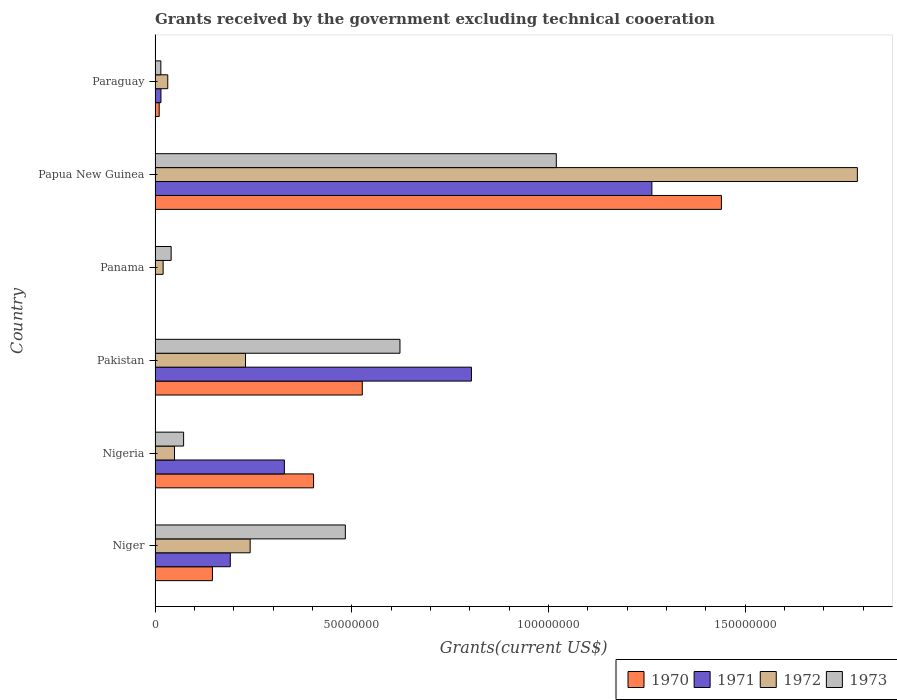How many groups of bars are there?
Offer a very short reply. 6. How many bars are there on the 1st tick from the top?
Ensure brevity in your answer.  4. What is the label of the 3rd group of bars from the top?
Provide a succinct answer. Panama. What is the total grants received by the government in 1973 in Pakistan?
Your answer should be compact. 6.23e+07. Across all countries, what is the maximum total grants received by the government in 1971?
Give a very brief answer. 1.26e+08. Across all countries, what is the minimum total grants received by the government in 1972?
Your response must be concise. 2.05e+06. In which country was the total grants received by the government in 1971 maximum?
Your response must be concise. Papua New Guinea. What is the total total grants received by the government in 1970 in the graph?
Provide a succinct answer. 2.53e+08. What is the difference between the total grants received by the government in 1973 in Papua New Guinea and that in Paraguay?
Provide a succinct answer. 1.01e+08. What is the difference between the total grants received by the government in 1972 in Nigeria and the total grants received by the government in 1973 in Niger?
Your answer should be compact. -4.34e+07. What is the average total grants received by the government in 1970 per country?
Keep it short and to the point. 4.21e+07. What is the difference between the total grants received by the government in 1970 and total grants received by the government in 1971 in Papua New Guinea?
Offer a very short reply. 1.77e+07. What is the ratio of the total grants received by the government in 1972 in Panama to that in Papua New Guinea?
Offer a very short reply. 0.01. Is the total grants received by the government in 1973 in Panama less than that in Paraguay?
Offer a very short reply. No. What is the difference between the highest and the second highest total grants received by the government in 1972?
Keep it short and to the point. 1.54e+08. What is the difference between the highest and the lowest total grants received by the government in 1971?
Your answer should be very brief. 1.26e+08. In how many countries, is the total grants received by the government in 1972 greater than the average total grants received by the government in 1972 taken over all countries?
Your answer should be compact. 1. Is the sum of the total grants received by the government in 1970 in Pakistan and Paraguay greater than the maximum total grants received by the government in 1973 across all countries?
Your answer should be compact. No. Is it the case that in every country, the sum of the total grants received by the government in 1971 and total grants received by the government in 1970 is greater than the sum of total grants received by the government in 1972 and total grants received by the government in 1973?
Your answer should be very brief. No. Are all the bars in the graph horizontal?
Provide a short and direct response. Yes. What is the difference between two consecutive major ticks on the X-axis?
Ensure brevity in your answer.  5.00e+07. Are the values on the major ticks of X-axis written in scientific E-notation?
Your response must be concise. No. Does the graph contain grids?
Provide a succinct answer. No. What is the title of the graph?
Your answer should be compact. Grants received by the government excluding technical cooeration. What is the label or title of the X-axis?
Offer a very short reply. Grants(current US$). What is the Grants(current US$) of 1970 in Niger?
Give a very brief answer. 1.46e+07. What is the Grants(current US$) in 1971 in Niger?
Make the answer very short. 1.91e+07. What is the Grants(current US$) in 1972 in Niger?
Give a very brief answer. 2.42e+07. What is the Grants(current US$) in 1973 in Niger?
Give a very brief answer. 4.84e+07. What is the Grants(current US$) of 1970 in Nigeria?
Offer a terse response. 4.03e+07. What is the Grants(current US$) in 1971 in Nigeria?
Offer a terse response. 3.29e+07. What is the Grants(current US$) of 1972 in Nigeria?
Your answer should be compact. 4.94e+06. What is the Grants(current US$) of 1973 in Nigeria?
Offer a very short reply. 7.26e+06. What is the Grants(current US$) in 1970 in Pakistan?
Provide a succinct answer. 5.27e+07. What is the Grants(current US$) of 1971 in Pakistan?
Keep it short and to the point. 8.04e+07. What is the Grants(current US$) of 1972 in Pakistan?
Your answer should be very brief. 2.30e+07. What is the Grants(current US$) of 1973 in Pakistan?
Make the answer very short. 6.23e+07. What is the Grants(current US$) in 1971 in Panama?
Offer a terse response. 1.10e+05. What is the Grants(current US$) of 1972 in Panama?
Provide a short and direct response. 2.05e+06. What is the Grants(current US$) in 1973 in Panama?
Your response must be concise. 4.09e+06. What is the Grants(current US$) in 1970 in Papua New Guinea?
Ensure brevity in your answer.  1.44e+08. What is the Grants(current US$) of 1971 in Papua New Guinea?
Offer a terse response. 1.26e+08. What is the Grants(current US$) in 1972 in Papua New Guinea?
Keep it short and to the point. 1.79e+08. What is the Grants(current US$) in 1973 in Papua New Guinea?
Give a very brief answer. 1.02e+08. What is the Grants(current US$) of 1970 in Paraguay?
Provide a short and direct response. 1.05e+06. What is the Grants(current US$) of 1971 in Paraguay?
Your answer should be very brief. 1.50e+06. What is the Grants(current US$) of 1972 in Paraguay?
Offer a very short reply. 3.23e+06. What is the Grants(current US$) in 1973 in Paraguay?
Your answer should be compact. 1.47e+06. Across all countries, what is the maximum Grants(current US$) in 1970?
Offer a very short reply. 1.44e+08. Across all countries, what is the maximum Grants(current US$) of 1971?
Offer a terse response. 1.26e+08. Across all countries, what is the maximum Grants(current US$) in 1972?
Provide a succinct answer. 1.79e+08. Across all countries, what is the maximum Grants(current US$) of 1973?
Your answer should be very brief. 1.02e+08. Across all countries, what is the minimum Grants(current US$) in 1970?
Your answer should be very brief. 0. Across all countries, what is the minimum Grants(current US$) in 1971?
Offer a terse response. 1.10e+05. Across all countries, what is the minimum Grants(current US$) in 1972?
Make the answer very short. 2.05e+06. Across all countries, what is the minimum Grants(current US$) of 1973?
Keep it short and to the point. 1.47e+06. What is the total Grants(current US$) of 1970 in the graph?
Provide a short and direct response. 2.53e+08. What is the total Grants(current US$) in 1971 in the graph?
Your answer should be very brief. 2.60e+08. What is the total Grants(current US$) of 1972 in the graph?
Make the answer very short. 2.36e+08. What is the total Grants(current US$) of 1973 in the graph?
Give a very brief answer. 2.25e+08. What is the difference between the Grants(current US$) in 1970 in Niger and that in Nigeria?
Provide a succinct answer. -2.57e+07. What is the difference between the Grants(current US$) of 1971 in Niger and that in Nigeria?
Give a very brief answer. -1.38e+07. What is the difference between the Grants(current US$) of 1972 in Niger and that in Nigeria?
Make the answer very short. 1.92e+07. What is the difference between the Grants(current US$) in 1973 in Niger and that in Nigeria?
Your answer should be compact. 4.11e+07. What is the difference between the Grants(current US$) of 1970 in Niger and that in Pakistan?
Make the answer very short. -3.81e+07. What is the difference between the Grants(current US$) of 1971 in Niger and that in Pakistan?
Make the answer very short. -6.13e+07. What is the difference between the Grants(current US$) of 1972 in Niger and that in Pakistan?
Keep it short and to the point. 1.18e+06. What is the difference between the Grants(current US$) in 1973 in Niger and that in Pakistan?
Your response must be concise. -1.39e+07. What is the difference between the Grants(current US$) of 1971 in Niger and that in Panama?
Your answer should be very brief. 1.90e+07. What is the difference between the Grants(current US$) in 1972 in Niger and that in Panama?
Provide a short and direct response. 2.21e+07. What is the difference between the Grants(current US$) of 1973 in Niger and that in Panama?
Your answer should be compact. 4.43e+07. What is the difference between the Grants(current US$) of 1970 in Niger and that in Papua New Guinea?
Your answer should be very brief. -1.29e+08. What is the difference between the Grants(current US$) of 1971 in Niger and that in Papua New Guinea?
Give a very brief answer. -1.07e+08. What is the difference between the Grants(current US$) in 1972 in Niger and that in Papua New Guinea?
Your response must be concise. -1.54e+08. What is the difference between the Grants(current US$) in 1973 in Niger and that in Papua New Guinea?
Offer a very short reply. -5.36e+07. What is the difference between the Grants(current US$) in 1970 in Niger and that in Paraguay?
Provide a short and direct response. 1.35e+07. What is the difference between the Grants(current US$) in 1971 in Niger and that in Paraguay?
Offer a very short reply. 1.76e+07. What is the difference between the Grants(current US$) of 1972 in Niger and that in Paraguay?
Provide a short and direct response. 2.10e+07. What is the difference between the Grants(current US$) in 1973 in Niger and that in Paraguay?
Your response must be concise. 4.69e+07. What is the difference between the Grants(current US$) in 1970 in Nigeria and that in Pakistan?
Give a very brief answer. -1.24e+07. What is the difference between the Grants(current US$) in 1971 in Nigeria and that in Pakistan?
Offer a very short reply. -4.76e+07. What is the difference between the Grants(current US$) of 1972 in Nigeria and that in Pakistan?
Keep it short and to the point. -1.81e+07. What is the difference between the Grants(current US$) in 1973 in Nigeria and that in Pakistan?
Give a very brief answer. -5.50e+07. What is the difference between the Grants(current US$) in 1971 in Nigeria and that in Panama?
Offer a terse response. 3.28e+07. What is the difference between the Grants(current US$) in 1972 in Nigeria and that in Panama?
Provide a succinct answer. 2.89e+06. What is the difference between the Grants(current US$) in 1973 in Nigeria and that in Panama?
Provide a succinct answer. 3.17e+06. What is the difference between the Grants(current US$) of 1970 in Nigeria and that in Papua New Guinea?
Offer a terse response. -1.04e+08. What is the difference between the Grants(current US$) in 1971 in Nigeria and that in Papua New Guinea?
Give a very brief answer. -9.34e+07. What is the difference between the Grants(current US$) in 1972 in Nigeria and that in Papua New Guinea?
Keep it short and to the point. -1.74e+08. What is the difference between the Grants(current US$) in 1973 in Nigeria and that in Papua New Guinea?
Ensure brevity in your answer.  -9.48e+07. What is the difference between the Grants(current US$) in 1970 in Nigeria and that in Paraguay?
Offer a very short reply. 3.92e+07. What is the difference between the Grants(current US$) in 1971 in Nigeria and that in Paraguay?
Your answer should be very brief. 3.14e+07. What is the difference between the Grants(current US$) in 1972 in Nigeria and that in Paraguay?
Your answer should be very brief. 1.71e+06. What is the difference between the Grants(current US$) of 1973 in Nigeria and that in Paraguay?
Your answer should be compact. 5.79e+06. What is the difference between the Grants(current US$) in 1971 in Pakistan and that in Panama?
Your answer should be compact. 8.03e+07. What is the difference between the Grants(current US$) in 1972 in Pakistan and that in Panama?
Your answer should be very brief. 2.10e+07. What is the difference between the Grants(current US$) of 1973 in Pakistan and that in Panama?
Offer a terse response. 5.82e+07. What is the difference between the Grants(current US$) of 1970 in Pakistan and that in Papua New Guinea?
Provide a succinct answer. -9.13e+07. What is the difference between the Grants(current US$) in 1971 in Pakistan and that in Papua New Guinea?
Provide a succinct answer. -4.59e+07. What is the difference between the Grants(current US$) of 1972 in Pakistan and that in Papua New Guinea?
Your response must be concise. -1.56e+08. What is the difference between the Grants(current US$) in 1973 in Pakistan and that in Papua New Guinea?
Keep it short and to the point. -3.98e+07. What is the difference between the Grants(current US$) of 1970 in Pakistan and that in Paraguay?
Your response must be concise. 5.16e+07. What is the difference between the Grants(current US$) of 1971 in Pakistan and that in Paraguay?
Make the answer very short. 7.89e+07. What is the difference between the Grants(current US$) in 1972 in Pakistan and that in Paraguay?
Make the answer very short. 1.98e+07. What is the difference between the Grants(current US$) of 1973 in Pakistan and that in Paraguay?
Offer a terse response. 6.08e+07. What is the difference between the Grants(current US$) in 1971 in Panama and that in Papua New Guinea?
Provide a short and direct response. -1.26e+08. What is the difference between the Grants(current US$) of 1972 in Panama and that in Papua New Guinea?
Provide a short and direct response. -1.77e+08. What is the difference between the Grants(current US$) in 1973 in Panama and that in Papua New Guinea?
Offer a very short reply. -9.79e+07. What is the difference between the Grants(current US$) in 1971 in Panama and that in Paraguay?
Keep it short and to the point. -1.39e+06. What is the difference between the Grants(current US$) of 1972 in Panama and that in Paraguay?
Give a very brief answer. -1.18e+06. What is the difference between the Grants(current US$) of 1973 in Panama and that in Paraguay?
Keep it short and to the point. 2.62e+06. What is the difference between the Grants(current US$) in 1970 in Papua New Guinea and that in Paraguay?
Your response must be concise. 1.43e+08. What is the difference between the Grants(current US$) of 1971 in Papua New Guinea and that in Paraguay?
Offer a terse response. 1.25e+08. What is the difference between the Grants(current US$) in 1972 in Papua New Guinea and that in Paraguay?
Your answer should be compact. 1.75e+08. What is the difference between the Grants(current US$) of 1973 in Papua New Guinea and that in Paraguay?
Your answer should be compact. 1.01e+08. What is the difference between the Grants(current US$) in 1970 in Niger and the Grants(current US$) in 1971 in Nigeria?
Provide a short and direct response. -1.83e+07. What is the difference between the Grants(current US$) in 1970 in Niger and the Grants(current US$) in 1972 in Nigeria?
Offer a terse response. 9.65e+06. What is the difference between the Grants(current US$) in 1970 in Niger and the Grants(current US$) in 1973 in Nigeria?
Your response must be concise. 7.33e+06. What is the difference between the Grants(current US$) in 1971 in Niger and the Grants(current US$) in 1972 in Nigeria?
Ensure brevity in your answer.  1.42e+07. What is the difference between the Grants(current US$) of 1971 in Niger and the Grants(current US$) of 1973 in Nigeria?
Keep it short and to the point. 1.19e+07. What is the difference between the Grants(current US$) of 1972 in Niger and the Grants(current US$) of 1973 in Nigeria?
Provide a short and direct response. 1.69e+07. What is the difference between the Grants(current US$) in 1970 in Niger and the Grants(current US$) in 1971 in Pakistan?
Give a very brief answer. -6.58e+07. What is the difference between the Grants(current US$) of 1970 in Niger and the Grants(current US$) of 1972 in Pakistan?
Provide a short and direct response. -8.41e+06. What is the difference between the Grants(current US$) in 1970 in Niger and the Grants(current US$) in 1973 in Pakistan?
Keep it short and to the point. -4.77e+07. What is the difference between the Grants(current US$) in 1971 in Niger and the Grants(current US$) in 1972 in Pakistan?
Your answer should be compact. -3.87e+06. What is the difference between the Grants(current US$) in 1971 in Niger and the Grants(current US$) in 1973 in Pakistan?
Make the answer very short. -4.31e+07. What is the difference between the Grants(current US$) of 1972 in Niger and the Grants(current US$) of 1973 in Pakistan?
Provide a short and direct response. -3.81e+07. What is the difference between the Grants(current US$) in 1970 in Niger and the Grants(current US$) in 1971 in Panama?
Your answer should be very brief. 1.45e+07. What is the difference between the Grants(current US$) in 1970 in Niger and the Grants(current US$) in 1972 in Panama?
Provide a short and direct response. 1.25e+07. What is the difference between the Grants(current US$) of 1970 in Niger and the Grants(current US$) of 1973 in Panama?
Provide a succinct answer. 1.05e+07. What is the difference between the Grants(current US$) of 1971 in Niger and the Grants(current US$) of 1972 in Panama?
Your answer should be compact. 1.71e+07. What is the difference between the Grants(current US$) in 1971 in Niger and the Grants(current US$) in 1973 in Panama?
Your answer should be compact. 1.50e+07. What is the difference between the Grants(current US$) of 1972 in Niger and the Grants(current US$) of 1973 in Panama?
Offer a terse response. 2.01e+07. What is the difference between the Grants(current US$) in 1970 in Niger and the Grants(current US$) in 1971 in Papua New Guinea?
Ensure brevity in your answer.  -1.12e+08. What is the difference between the Grants(current US$) in 1970 in Niger and the Grants(current US$) in 1972 in Papua New Guinea?
Offer a very short reply. -1.64e+08. What is the difference between the Grants(current US$) in 1970 in Niger and the Grants(current US$) in 1973 in Papua New Guinea?
Your response must be concise. -8.74e+07. What is the difference between the Grants(current US$) in 1971 in Niger and the Grants(current US$) in 1972 in Papua New Guinea?
Provide a succinct answer. -1.59e+08. What is the difference between the Grants(current US$) of 1971 in Niger and the Grants(current US$) of 1973 in Papua New Guinea?
Your answer should be compact. -8.29e+07. What is the difference between the Grants(current US$) in 1972 in Niger and the Grants(current US$) in 1973 in Papua New Guinea?
Offer a very short reply. -7.78e+07. What is the difference between the Grants(current US$) of 1970 in Niger and the Grants(current US$) of 1971 in Paraguay?
Keep it short and to the point. 1.31e+07. What is the difference between the Grants(current US$) of 1970 in Niger and the Grants(current US$) of 1972 in Paraguay?
Offer a terse response. 1.14e+07. What is the difference between the Grants(current US$) in 1970 in Niger and the Grants(current US$) in 1973 in Paraguay?
Your answer should be compact. 1.31e+07. What is the difference between the Grants(current US$) of 1971 in Niger and the Grants(current US$) of 1972 in Paraguay?
Offer a terse response. 1.59e+07. What is the difference between the Grants(current US$) in 1971 in Niger and the Grants(current US$) in 1973 in Paraguay?
Your response must be concise. 1.77e+07. What is the difference between the Grants(current US$) of 1972 in Niger and the Grants(current US$) of 1973 in Paraguay?
Ensure brevity in your answer.  2.27e+07. What is the difference between the Grants(current US$) of 1970 in Nigeria and the Grants(current US$) of 1971 in Pakistan?
Make the answer very short. -4.01e+07. What is the difference between the Grants(current US$) of 1970 in Nigeria and the Grants(current US$) of 1972 in Pakistan?
Offer a very short reply. 1.73e+07. What is the difference between the Grants(current US$) in 1970 in Nigeria and the Grants(current US$) in 1973 in Pakistan?
Provide a short and direct response. -2.20e+07. What is the difference between the Grants(current US$) in 1971 in Nigeria and the Grants(current US$) in 1972 in Pakistan?
Ensure brevity in your answer.  9.88e+06. What is the difference between the Grants(current US$) in 1971 in Nigeria and the Grants(current US$) in 1973 in Pakistan?
Your answer should be very brief. -2.94e+07. What is the difference between the Grants(current US$) in 1972 in Nigeria and the Grants(current US$) in 1973 in Pakistan?
Your response must be concise. -5.73e+07. What is the difference between the Grants(current US$) in 1970 in Nigeria and the Grants(current US$) in 1971 in Panama?
Your response must be concise. 4.02e+07. What is the difference between the Grants(current US$) in 1970 in Nigeria and the Grants(current US$) in 1972 in Panama?
Your answer should be very brief. 3.82e+07. What is the difference between the Grants(current US$) of 1970 in Nigeria and the Grants(current US$) of 1973 in Panama?
Your answer should be very brief. 3.62e+07. What is the difference between the Grants(current US$) in 1971 in Nigeria and the Grants(current US$) in 1972 in Panama?
Your response must be concise. 3.08e+07. What is the difference between the Grants(current US$) in 1971 in Nigeria and the Grants(current US$) in 1973 in Panama?
Offer a terse response. 2.88e+07. What is the difference between the Grants(current US$) in 1972 in Nigeria and the Grants(current US$) in 1973 in Panama?
Your answer should be compact. 8.50e+05. What is the difference between the Grants(current US$) of 1970 in Nigeria and the Grants(current US$) of 1971 in Papua New Guinea?
Make the answer very short. -8.60e+07. What is the difference between the Grants(current US$) in 1970 in Nigeria and the Grants(current US$) in 1972 in Papua New Guinea?
Offer a very short reply. -1.38e+08. What is the difference between the Grants(current US$) of 1970 in Nigeria and the Grants(current US$) of 1973 in Papua New Guinea?
Give a very brief answer. -6.17e+07. What is the difference between the Grants(current US$) of 1971 in Nigeria and the Grants(current US$) of 1972 in Papua New Guinea?
Offer a terse response. -1.46e+08. What is the difference between the Grants(current US$) in 1971 in Nigeria and the Grants(current US$) in 1973 in Papua New Guinea?
Offer a very short reply. -6.91e+07. What is the difference between the Grants(current US$) of 1972 in Nigeria and the Grants(current US$) of 1973 in Papua New Guinea?
Provide a short and direct response. -9.71e+07. What is the difference between the Grants(current US$) of 1970 in Nigeria and the Grants(current US$) of 1971 in Paraguay?
Ensure brevity in your answer.  3.88e+07. What is the difference between the Grants(current US$) of 1970 in Nigeria and the Grants(current US$) of 1972 in Paraguay?
Your answer should be very brief. 3.71e+07. What is the difference between the Grants(current US$) in 1970 in Nigeria and the Grants(current US$) in 1973 in Paraguay?
Make the answer very short. 3.88e+07. What is the difference between the Grants(current US$) in 1971 in Nigeria and the Grants(current US$) in 1972 in Paraguay?
Offer a terse response. 2.96e+07. What is the difference between the Grants(current US$) in 1971 in Nigeria and the Grants(current US$) in 1973 in Paraguay?
Your response must be concise. 3.14e+07. What is the difference between the Grants(current US$) in 1972 in Nigeria and the Grants(current US$) in 1973 in Paraguay?
Give a very brief answer. 3.47e+06. What is the difference between the Grants(current US$) in 1970 in Pakistan and the Grants(current US$) in 1971 in Panama?
Offer a very short reply. 5.26e+07. What is the difference between the Grants(current US$) of 1970 in Pakistan and the Grants(current US$) of 1972 in Panama?
Your response must be concise. 5.06e+07. What is the difference between the Grants(current US$) of 1970 in Pakistan and the Grants(current US$) of 1973 in Panama?
Provide a succinct answer. 4.86e+07. What is the difference between the Grants(current US$) of 1971 in Pakistan and the Grants(current US$) of 1972 in Panama?
Give a very brief answer. 7.84e+07. What is the difference between the Grants(current US$) of 1971 in Pakistan and the Grants(current US$) of 1973 in Panama?
Your answer should be compact. 7.64e+07. What is the difference between the Grants(current US$) in 1972 in Pakistan and the Grants(current US$) in 1973 in Panama?
Your answer should be very brief. 1.89e+07. What is the difference between the Grants(current US$) in 1970 in Pakistan and the Grants(current US$) in 1971 in Papua New Guinea?
Provide a succinct answer. -7.36e+07. What is the difference between the Grants(current US$) of 1970 in Pakistan and the Grants(current US$) of 1972 in Papua New Guinea?
Keep it short and to the point. -1.26e+08. What is the difference between the Grants(current US$) in 1970 in Pakistan and the Grants(current US$) in 1973 in Papua New Guinea?
Offer a very short reply. -4.93e+07. What is the difference between the Grants(current US$) of 1971 in Pakistan and the Grants(current US$) of 1972 in Papua New Guinea?
Give a very brief answer. -9.81e+07. What is the difference between the Grants(current US$) in 1971 in Pakistan and the Grants(current US$) in 1973 in Papua New Guinea?
Make the answer very short. -2.16e+07. What is the difference between the Grants(current US$) in 1972 in Pakistan and the Grants(current US$) in 1973 in Papua New Guinea?
Your answer should be compact. -7.90e+07. What is the difference between the Grants(current US$) in 1970 in Pakistan and the Grants(current US$) in 1971 in Paraguay?
Give a very brief answer. 5.12e+07. What is the difference between the Grants(current US$) of 1970 in Pakistan and the Grants(current US$) of 1972 in Paraguay?
Keep it short and to the point. 4.95e+07. What is the difference between the Grants(current US$) in 1970 in Pakistan and the Grants(current US$) in 1973 in Paraguay?
Offer a terse response. 5.12e+07. What is the difference between the Grants(current US$) of 1971 in Pakistan and the Grants(current US$) of 1972 in Paraguay?
Make the answer very short. 7.72e+07. What is the difference between the Grants(current US$) in 1971 in Pakistan and the Grants(current US$) in 1973 in Paraguay?
Make the answer very short. 7.90e+07. What is the difference between the Grants(current US$) of 1972 in Pakistan and the Grants(current US$) of 1973 in Paraguay?
Offer a terse response. 2.15e+07. What is the difference between the Grants(current US$) of 1971 in Panama and the Grants(current US$) of 1972 in Papua New Guinea?
Make the answer very short. -1.78e+08. What is the difference between the Grants(current US$) in 1971 in Panama and the Grants(current US$) in 1973 in Papua New Guinea?
Your answer should be very brief. -1.02e+08. What is the difference between the Grants(current US$) in 1972 in Panama and the Grants(current US$) in 1973 in Papua New Guinea?
Your answer should be very brief. -1.00e+08. What is the difference between the Grants(current US$) of 1971 in Panama and the Grants(current US$) of 1972 in Paraguay?
Ensure brevity in your answer.  -3.12e+06. What is the difference between the Grants(current US$) of 1971 in Panama and the Grants(current US$) of 1973 in Paraguay?
Your response must be concise. -1.36e+06. What is the difference between the Grants(current US$) of 1972 in Panama and the Grants(current US$) of 1973 in Paraguay?
Give a very brief answer. 5.80e+05. What is the difference between the Grants(current US$) of 1970 in Papua New Guinea and the Grants(current US$) of 1971 in Paraguay?
Offer a very short reply. 1.42e+08. What is the difference between the Grants(current US$) in 1970 in Papua New Guinea and the Grants(current US$) in 1972 in Paraguay?
Provide a short and direct response. 1.41e+08. What is the difference between the Grants(current US$) of 1970 in Papua New Guinea and the Grants(current US$) of 1973 in Paraguay?
Offer a terse response. 1.43e+08. What is the difference between the Grants(current US$) in 1971 in Papua New Guinea and the Grants(current US$) in 1972 in Paraguay?
Provide a short and direct response. 1.23e+08. What is the difference between the Grants(current US$) in 1971 in Papua New Guinea and the Grants(current US$) in 1973 in Paraguay?
Keep it short and to the point. 1.25e+08. What is the difference between the Grants(current US$) of 1972 in Papua New Guinea and the Grants(current US$) of 1973 in Paraguay?
Your answer should be very brief. 1.77e+08. What is the average Grants(current US$) of 1970 per country?
Ensure brevity in your answer.  4.21e+07. What is the average Grants(current US$) of 1971 per country?
Make the answer very short. 4.34e+07. What is the average Grants(current US$) in 1972 per country?
Your answer should be compact. 3.93e+07. What is the average Grants(current US$) of 1973 per country?
Your answer should be compact. 3.76e+07. What is the difference between the Grants(current US$) of 1970 and Grants(current US$) of 1971 in Niger?
Offer a very short reply. -4.54e+06. What is the difference between the Grants(current US$) in 1970 and Grants(current US$) in 1972 in Niger?
Your response must be concise. -9.59e+06. What is the difference between the Grants(current US$) in 1970 and Grants(current US$) in 1973 in Niger?
Offer a terse response. -3.38e+07. What is the difference between the Grants(current US$) in 1971 and Grants(current US$) in 1972 in Niger?
Your response must be concise. -5.05e+06. What is the difference between the Grants(current US$) in 1971 and Grants(current US$) in 1973 in Niger?
Your answer should be compact. -2.92e+07. What is the difference between the Grants(current US$) of 1972 and Grants(current US$) of 1973 in Niger?
Give a very brief answer. -2.42e+07. What is the difference between the Grants(current US$) of 1970 and Grants(current US$) of 1971 in Nigeria?
Ensure brevity in your answer.  7.42e+06. What is the difference between the Grants(current US$) in 1970 and Grants(current US$) in 1972 in Nigeria?
Ensure brevity in your answer.  3.54e+07. What is the difference between the Grants(current US$) of 1970 and Grants(current US$) of 1973 in Nigeria?
Ensure brevity in your answer.  3.30e+07. What is the difference between the Grants(current US$) of 1971 and Grants(current US$) of 1972 in Nigeria?
Provide a succinct answer. 2.79e+07. What is the difference between the Grants(current US$) in 1971 and Grants(current US$) in 1973 in Nigeria?
Offer a terse response. 2.56e+07. What is the difference between the Grants(current US$) of 1972 and Grants(current US$) of 1973 in Nigeria?
Your response must be concise. -2.32e+06. What is the difference between the Grants(current US$) in 1970 and Grants(current US$) in 1971 in Pakistan?
Make the answer very short. -2.78e+07. What is the difference between the Grants(current US$) in 1970 and Grants(current US$) in 1972 in Pakistan?
Ensure brevity in your answer.  2.97e+07. What is the difference between the Grants(current US$) of 1970 and Grants(current US$) of 1973 in Pakistan?
Provide a succinct answer. -9.58e+06. What is the difference between the Grants(current US$) of 1971 and Grants(current US$) of 1972 in Pakistan?
Keep it short and to the point. 5.74e+07. What is the difference between the Grants(current US$) of 1971 and Grants(current US$) of 1973 in Pakistan?
Provide a short and direct response. 1.82e+07. What is the difference between the Grants(current US$) of 1972 and Grants(current US$) of 1973 in Pakistan?
Give a very brief answer. -3.93e+07. What is the difference between the Grants(current US$) of 1971 and Grants(current US$) of 1972 in Panama?
Your answer should be very brief. -1.94e+06. What is the difference between the Grants(current US$) in 1971 and Grants(current US$) in 1973 in Panama?
Your response must be concise. -3.98e+06. What is the difference between the Grants(current US$) of 1972 and Grants(current US$) of 1973 in Panama?
Keep it short and to the point. -2.04e+06. What is the difference between the Grants(current US$) of 1970 and Grants(current US$) of 1971 in Papua New Guinea?
Your response must be concise. 1.77e+07. What is the difference between the Grants(current US$) of 1970 and Grants(current US$) of 1972 in Papua New Guinea?
Your response must be concise. -3.46e+07. What is the difference between the Grants(current US$) in 1970 and Grants(current US$) in 1973 in Papua New Guinea?
Offer a very short reply. 4.20e+07. What is the difference between the Grants(current US$) in 1971 and Grants(current US$) in 1972 in Papua New Guinea?
Your answer should be compact. -5.22e+07. What is the difference between the Grants(current US$) of 1971 and Grants(current US$) of 1973 in Papua New Guinea?
Give a very brief answer. 2.43e+07. What is the difference between the Grants(current US$) of 1972 and Grants(current US$) of 1973 in Papua New Guinea?
Your answer should be compact. 7.66e+07. What is the difference between the Grants(current US$) in 1970 and Grants(current US$) in 1971 in Paraguay?
Offer a very short reply. -4.50e+05. What is the difference between the Grants(current US$) of 1970 and Grants(current US$) of 1972 in Paraguay?
Offer a very short reply. -2.18e+06. What is the difference between the Grants(current US$) of 1970 and Grants(current US$) of 1973 in Paraguay?
Give a very brief answer. -4.20e+05. What is the difference between the Grants(current US$) of 1971 and Grants(current US$) of 1972 in Paraguay?
Offer a terse response. -1.73e+06. What is the difference between the Grants(current US$) in 1971 and Grants(current US$) in 1973 in Paraguay?
Provide a short and direct response. 3.00e+04. What is the difference between the Grants(current US$) of 1972 and Grants(current US$) of 1973 in Paraguay?
Offer a terse response. 1.76e+06. What is the ratio of the Grants(current US$) of 1970 in Niger to that in Nigeria?
Your response must be concise. 0.36. What is the ratio of the Grants(current US$) of 1971 in Niger to that in Nigeria?
Give a very brief answer. 0.58. What is the ratio of the Grants(current US$) in 1972 in Niger to that in Nigeria?
Make the answer very short. 4.89. What is the ratio of the Grants(current US$) in 1973 in Niger to that in Nigeria?
Offer a terse response. 6.66. What is the ratio of the Grants(current US$) of 1970 in Niger to that in Pakistan?
Your answer should be compact. 0.28. What is the ratio of the Grants(current US$) in 1971 in Niger to that in Pakistan?
Ensure brevity in your answer.  0.24. What is the ratio of the Grants(current US$) in 1972 in Niger to that in Pakistan?
Provide a succinct answer. 1.05. What is the ratio of the Grants(current US$) in 1973 in Niger to that in Pakistan?
Offer a very short reply. 0.78. What is the ratio of the Grants(current US$) of 1971 in Niger to that in Panama?
Your response must be concise. 173.91. What is the ratio of the Grants(current US$) in 1972 in Niger to that in Panama?
Keep it short and to the point. 11.8. What is the ratio of the Grants(current US$) of 1973 in Niger to that in Panama?
Provide a short and direct response. 11.83. What is the ratio of the Grants(current US$) in 1970 in Niger to that in Papua New Guinea?
Offer a terse response. 0.1. What is the ratio of the Grants(current US$) of 1971 in Niger to that in Papua New Guinea?
Ensure brevity in your answer.  0.15. What is the ratio of the Grants(current US$) in 1972 in Niger to that in Papua New Guinea?
Give a very brief answer. 0.14. What is the ratio of the Grants(current US$) in 1973 in Niger to that in Papua New Guinea?
Provide a succinct answer. 0.47. What is the ratio of the Grants(current US$) in 1970 in Niger to that in Paraguay?
Ensure brevity in your answer.  13.9. What is the ratio of the Grants(current US$) in 1971 in Niger to that in Paraguay?
Offer a very short reply. 12.75. What is the ratio of the Grants(current US$) in 1972 in Niger to that in Paraguay?
Make the answer very short. 7.49. What is the ratio of the Grants(current US$) of 1973 in Niger to that in Paraguay?
Ensure brevity in your answer.  32.91. What is the ratio of the Grants(current US$) of 1970 in Nigeria to that in Pakistan?
Provide a succinct answer. 0.76. What is the ratio of the Grants(current US$) of 1971 in Nigeria to that in Pakistan?
Your answer should be very brief. 0.41. What is the ratio of the Grants(current US$) of 1972 in Nigeria to that in Pakistan?
Keep it short and to the point. 0.21. What is the ratio of the Grants(current US$) of 1973 in Nigeria to that in Pakistan?
Offer a very short reply. 0.12. What is the ratio of the Grants(current US$) in 1971 in Nigeria to that in Panama?
Provide a short and direct response. 298.91. What is the ratio of the Grants(current US$) of 1972 in Nigeria to that in Panama?
Provide a short and direct response. 2.41. What is the ratio of the Grants(current US$) in 1973 in Nigeria to that in Panama?
Provide a short and direct response. 1.78. What is the ratio of the Grants(current US$) in 1970 in Nigeria to that in Papua New Guinea?
Ensure brevity in your answer.  0.28. What is the ratio of the Grants(current US$) of 1971 in Nigeria to that in Papua New Guinea?
Ensure brevity in your answer.  0.26. What is the ratio of the Grants(current US$) of 1972 in Nigeria to that in Papua New Guinea?
Your response must be concise. 0.03. What is the ratio of the Grants(current US$) in 1973 in Nigeria to that in Papua New Guinea?
Provide a succinct answer. 0.07. What is the ratio of the Grants(current US$) of 1970 in Nigeria to that in Paraguay?
Provide a short and direct response. 38.38. What is the ratio of the Grants(current US$) in 1971 in Nigeria to that in Paraguay?
Offer a very short reply. 21.92. What is the ratio of the Grants(current US$) in 1972 in Nigeria to that in Paraguay?
Keep it short and to the point. 1.53. What is the ratio of the Grants(current US$) in 1973 in Nigeria to that in Paraguay?
Keep it short and to the point. 4.94. What is the ratio of the Grants(current US$) in 1971 in Pakistan to that in Panama?
Give a very brief answer. 731.27. What is the ratio of the Grants(current US$) in 1972 in Pakistan to that in Panama?
Make the answer very short. 11.22. What is the ratio of the Grants(current US$) of 1973 in Pakistan to that in Panama?
Your response must be concise. 15.22. What is the ratio of the Grants(current US$) of 1970 in Pakistan to that in Papua New Guinea?
Offer a very short reply. 0.37. What is the ratio of the Grants(current US$) in 1971 in Pakistan to that in Papua New Guinea?
Provide a short and direct response. 0.64. What is the ratio of the Grants(current US$) of 1972 in Pakistan to that in Papua New Guinea?
Ensure brevity in your answer.  0.13. What is the ratio of the Grants(current US$) of 1973 in Pakistan to that in Papua New Guinea?
Offer a terse response. 0.61. What is the ratio of the Grants(current US$) of 1970 in Pakistan to that in Paraguay?
Provide a short and direct response. 50.18. What is the ratio of the Grants(current US$) of 1971 in Pakistan to that in Paraguay?
Provide a short and direct response. 53.63. What is the ratio of the Grants(current US$) of 1972 in Pakistan to that in Paraguay?
Make the answer very short. 7.12. What is the ratio of the Grants(current US$) of 1973 in Pakistan to that in Paraguay?
Provide a succinct answer. 42.36. What is the ratio of the Grants(current US$) of 1971 in Panama to that in Papua New Guinea?
Provide a succinct answer. 0. What is the ratio of the Grants(current US$) in 1972 in Panama to that in Papua New Guinea?
Ensure brevity in your answer.  0.01. What is the ratio of the Grants(current US$) of 1973 in Panama to that in Papua New Guinea?
Ensure brevity in your answer.  0.04. What is the ratio of the Grants(current US$) of 1971 in Panama to that in Paraguay?
Ensure brevity in your answer.  0.07. What is the ratio of the Grants(current US$) in 1972 in Panama to that in Paraguay?
Your response must be concise. 0.63. What is the ratio of the Grants(current US$) in 1973 in Panama to that in Paraguay?
Provide a short and direct response. 2.78. What is the ratio of the Grants(current US$) in 1970 in Papua New Guinea to that in Paraguay?
Make the answer very short. 137.14. What is the ratio of the Grants(current US$) in 1971 in Papua New Guinea to that in Paraguay?
Give a very brief answer. 84.21. What is the ratio of the Grants(current US$) in 1972 in Papua New Guinea to that in Paraguay?
Provide a succinct answer. 55.28. What is the ratio of the Grants(current US$) in 1973 in Papua New Guinea to that in Paraguay?
Make the answer very short. 69.4. What is the difference between the highest and the second highest Grants(current US$) of 1970?
Your answer should be compact. 9.13e+07. What is the difference between the highest and the second highest Grants(current US$) of 1971?
Offer a terse response. 4.59e+07. What is the difference between the highest and the second highest Grants(current US$) in 1972?
Your response must be concise. 1.54e+08. What is the difference between the highest and the second highest Grants(current US$) of 1973?
Provide a succinct answer. 3.98e+07. What is the difference between the highest and the lowest Grants(current US$) in 1970?
Your answer should be compact. 1.44e+08. What is the difference between the highest and the lowest Grants(current US$) in 1971?
Your response must be concise. 1.26e+08. What is the difference between the highest and the lowest Grants(current US$) of 1972?
Offer a very short reply. 1.77e+08. What is the difference between the highest and the lowest Grants(current US$) of 1973?
Your response must be concise. 1.01e+08. 